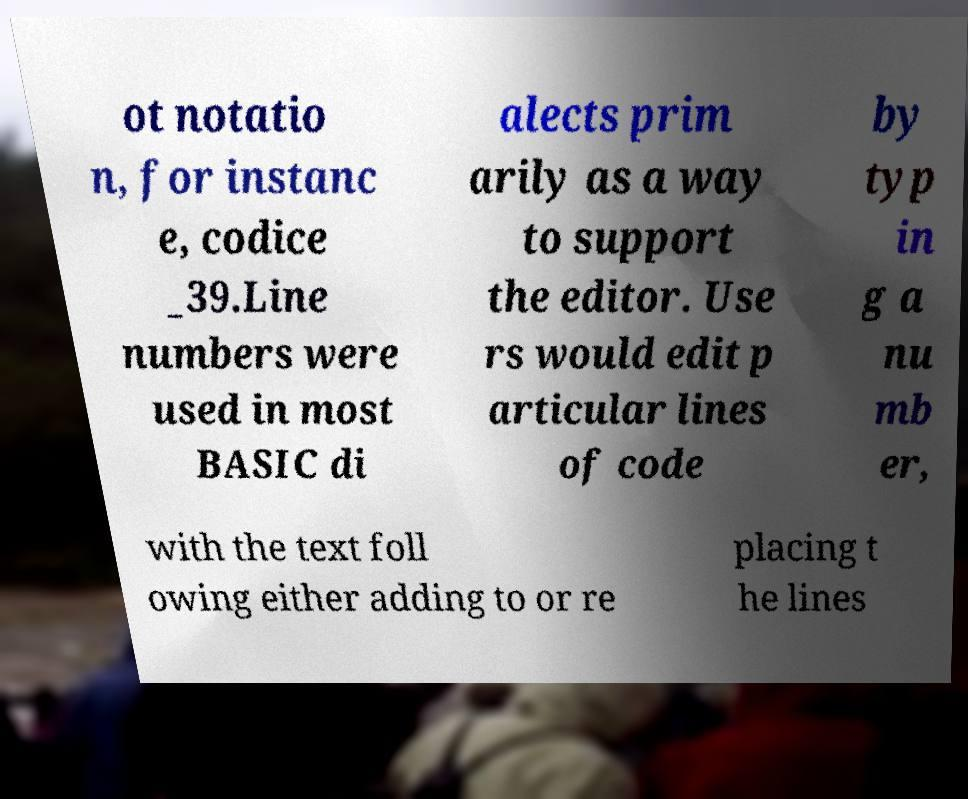Can you accurately transcribe the text from the provided image for me? ot notatio n, for instanc e, codice _39.Line numbers were used in most BASIC di alects prim arily as a way to support the editor. Use rs would edit p articular lines of code by typ in g a nu mb er, with the text foll owing either adding to or re placing t he lines 